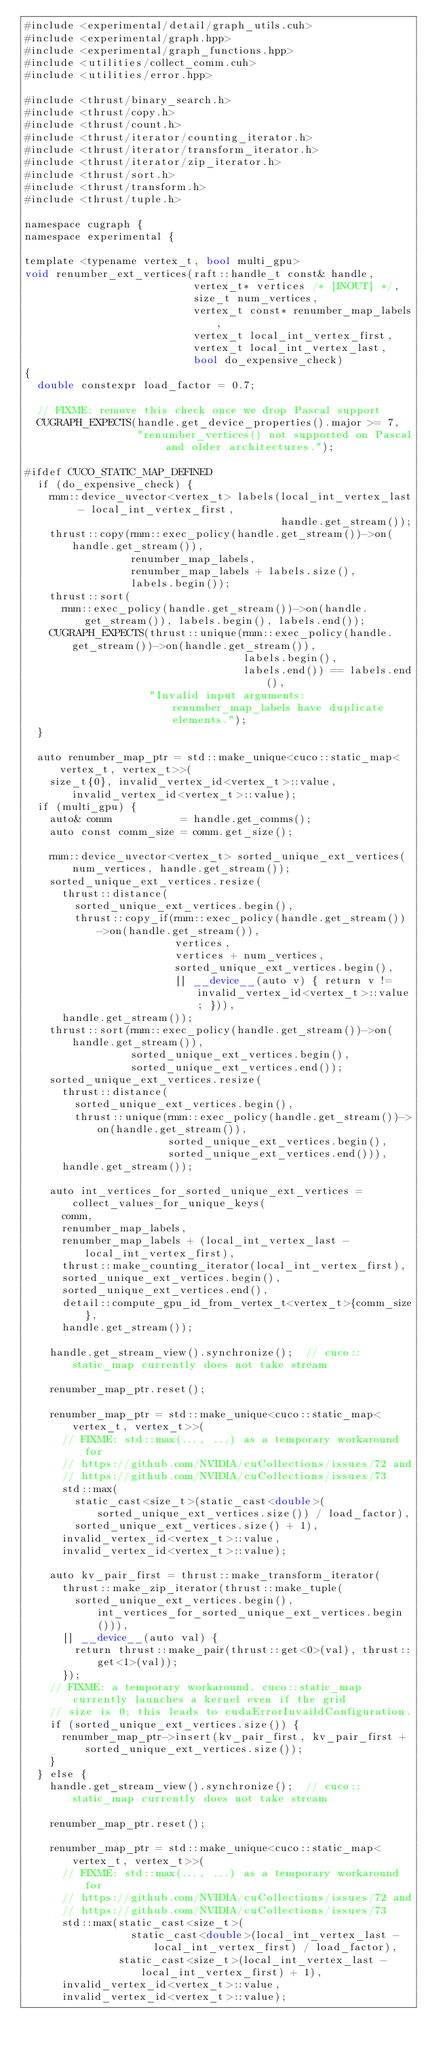Convert code to text. <code><loc_0><loc_0><loc_500><loc_500><_Cuda_>#include <experimental/detail/graph_utils.cuh>
#include <experimental/graph.hpp>
#include <experimental/graph_functions.hpp>
#include <utilities/collect_comm.cuh>
#include <utilities/error.hpp>

#include <thrust/binary_search.h>
#include <thrust/copy.h>
#include <thrust/count.h>
#include <thrust/iterator/counting_iterator.h>
#include <thrust/iterator/transform_iterator.h>
#include <thrust/iterator/zip_iterator.h>
#include <thrust/sort.h>
#include <thrust/transform.h>
#include <thrust/tuple.h>

namespace cugraph {
namespace experimental {

template <typename vertex_t, bool multi_gpu>
void renumber_ext_vertices(raft::handle_t const& handle,
                           vertex_t* vertices /* [INOUT] */,
                           size_t num_vertices,
                           vertex_t const* renumber_map_labels,
                           vertex_t local_int_vertex_first,
                           vertex_t local_int_vertex_last,
                           bool do_expensive_check)
{
  double constexpr load_factor = 0.7;

  // FIXME: remove this check once we drop Pascal support
  CUGRAPH_EXPECTS(handle.get_device_properties().major >= 7,
                  "renumber_vertices() not supported on Pascal and older architectures.");

#ifdef CUCO_STATIC_MAP_DEFINED
  if (do_expensive_check) {
    rmm::device_uvector<vertex_t> labels(local_int_vertex_last - local_int_vertex_first,
                                         handle.get_stream());
    thrust::copy(rmm::exec_policy(handle.get_stream())->on(handle.get_stream()),
                 renumber_map_labels,
                 renumber_map_labels + labels.size(),
                 labels.begin());
    thrust::sort(
      rmm::exec_policy(handle.get_stream())->on(handle.get_stream()), labels.begin(), labels.end());
    CUGRAPH_EXPECTS(thrust::unique(rmm::exec_policy(handle.get_stream())->on(handle.get_stream()),
                                   labels.begin(),
                                   labels.end()) == labels.end(),
                    "Invalid input arguments: renumber_map_labels have duplicate elements.");
  }

  auto renumber_map_ptr = std::make_unique<cuco::static_map<vertex_t, vertex_t>>(
    size_t{0}, invalid_vertex_id<vertex_t>::value, invalid_vertex_id<vertex_t>::value);
  if (multi_gpu) {
    auto& comm           = handle.get_comms();
    auto const comm_size = comm.get_size();

    rmm::device_uvector<vertex_t> sorted_unique_ext_vertices(num_vertices, handle.get_stream());
    sorted_unique_ext_vertices.resize(
      thrust::distance(
        sorted_unique_ext_vertices.begin(),
        thrust::copy_if(rmm::exec_policy(handle.get_stream())->on(handle.get_stream()),
                        vertices,
                        vertices + num_vertices,
                        sorted_unique_ext_vertices.begin(),
                        [] __device__(auto v) { return v != invalid_vertex_id<vertex_t>::value; })),
      handle.get_stream());
    thrust::sort(rmm::exec_policy(handle.get_stream())->on(handle.get_stream()),
                 sorted_unique_ext_vertices.begin(),
                 sorted_unique_ext_vertices.end());
    sorted_unique_ext_vertices.resize(
      thrust::distance(
        sorted_unique_ext_vertices.begin(),
        thrust::unique(rmm::exec_policy(handle.get_stream())->on(handle.get_stream()),
                       sorted_unique_ext_vertices.begin(),
                       sorted_unique_ext_vertices.end())),
      handle.get_stream());

    auto int_vertices_for_sorted_unique_ext_vertices = collect_values_for_unique_keys(
      comm,
      renumber_map_labels,
      renumber_map_labels + (local_int_vertex_last - local_int_vertex_first),
      thrust::make_counting_iterator(local_int_vertex_first),
      sorted_unique_ext_vertices.begin(),
      sorted_unique_ext_vertices.end(),
      detail::compute_gpu_id_from_vertex_t<vertex_t>{comm_size},
      handle.get_stream());

    handle.get_stream_view().synchronize();  // cuco::static_map currently does not take stream

    renumber_map_ptr.reset();

    renumber_map_ptr = std::make_unique<cuco::static_map<vertex_t, vertex_t>>(
      // FIXME: std::max(..., ...) as a temporary workaround for
      // https://github.com/NVIDIA/cuCollections/issues/72 and
      // https://github.com/NVIDIA/cuCollections/issues/73
      std::max(
        static_cast<size_t>(static_cast<double>(sorted_unique_ext_vertices.size()) / load_factor),
        sorted_unique_ext_vertices.size() + 1),
      invalid_vertex_id<vertex_t>::value,
      invalid_vertex_id<vertex_t>::value);

    auto kv_pair_first = thrust::make_transform_iterator(
      thrust::make_zip_iterator(thrust::make_tuple(
        sorted_unique_ext_vertices.begin(), int_vertices_for_sorted_unique_ext_vertices.begin())),
      [] __device__(auto val) {
        return thrust::make_pair(thrust::get<0>(val), thrust::get<1>(val));
      });
    // FIXME: a temporary workaround. cuco::static_map currently launches a kernel even if the grid
    // size is 0; this leads to cudaErrorInvaildConfiguration.
    if (sorted_unique_ext_vertices.size()) {
      renumber_map_ptr->insert(kv_pair_first, kv_pair_first + sorted_unique_ext_vertices.size());
    }
  } else {
    handle.get_stream_view().synchronize();  // cuco::static_map currently does not take stream

    renumber_map_ptr.reset();

    renumber_map_ptr = std::make_unique<cuco::static_map<vertex_t, vertex_t>>(
      // FIXME: std::max(..., ...) as a temporary workaround for
      // https://github.com/NVIDIA/cuCollections/issues/72 and
      // https://github.com/NVIDIA/cuCollections/issues/73
      std::max(static_cast<size_t>(
                 static_cast<double>(local_int_vertex_last - local_int_vertex_first) / load_factor),
               static_cast<size_t>(local_int_vertex_last - local_int_vertex_first) + 1),
      invalid_vertex_id<vertex_t>::value,
      invalid_vertex_id<vertex_t>::value);
</code> 